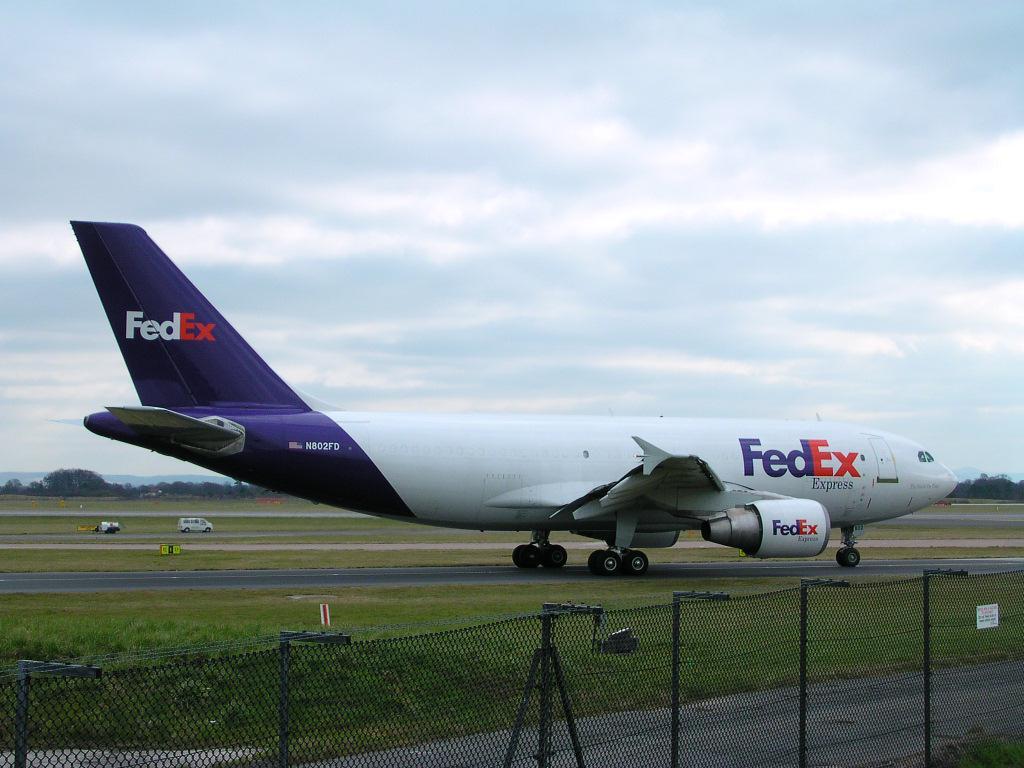What brand is this phone?
Ensure brevity in your answer.  Unanswerable. Is the word express under the word fedex at the front of the plane?
Keep it short and to the point. Yes. 